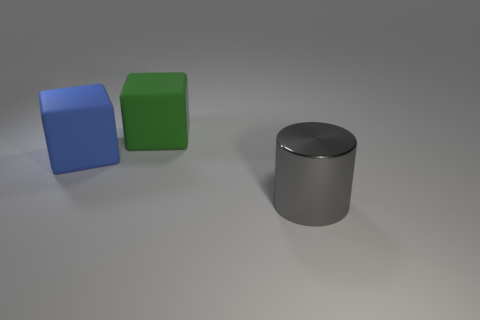Add 3 cubes. How many objects exist? 6 Subtract all blocks. How many objects are left? 1 Add 3 big green blocks. How many big green blocks are left? 4 Add 3 large blue rubber blocks. How many large blue rubber blocks exist? 4 Subtract 0 red cubes. How many objects are left? 3 Subtract all big cylinders. Subtract all large blue metal cylinders. How many objects are left? 2 